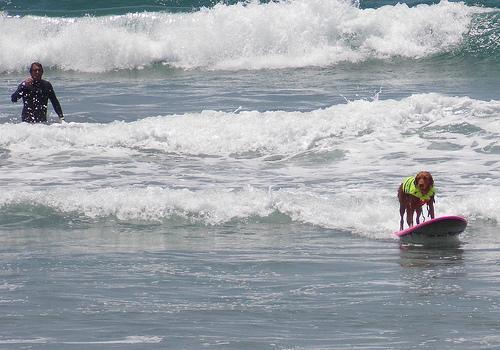How many people are in the water?
Give a very brief answer. 1. 